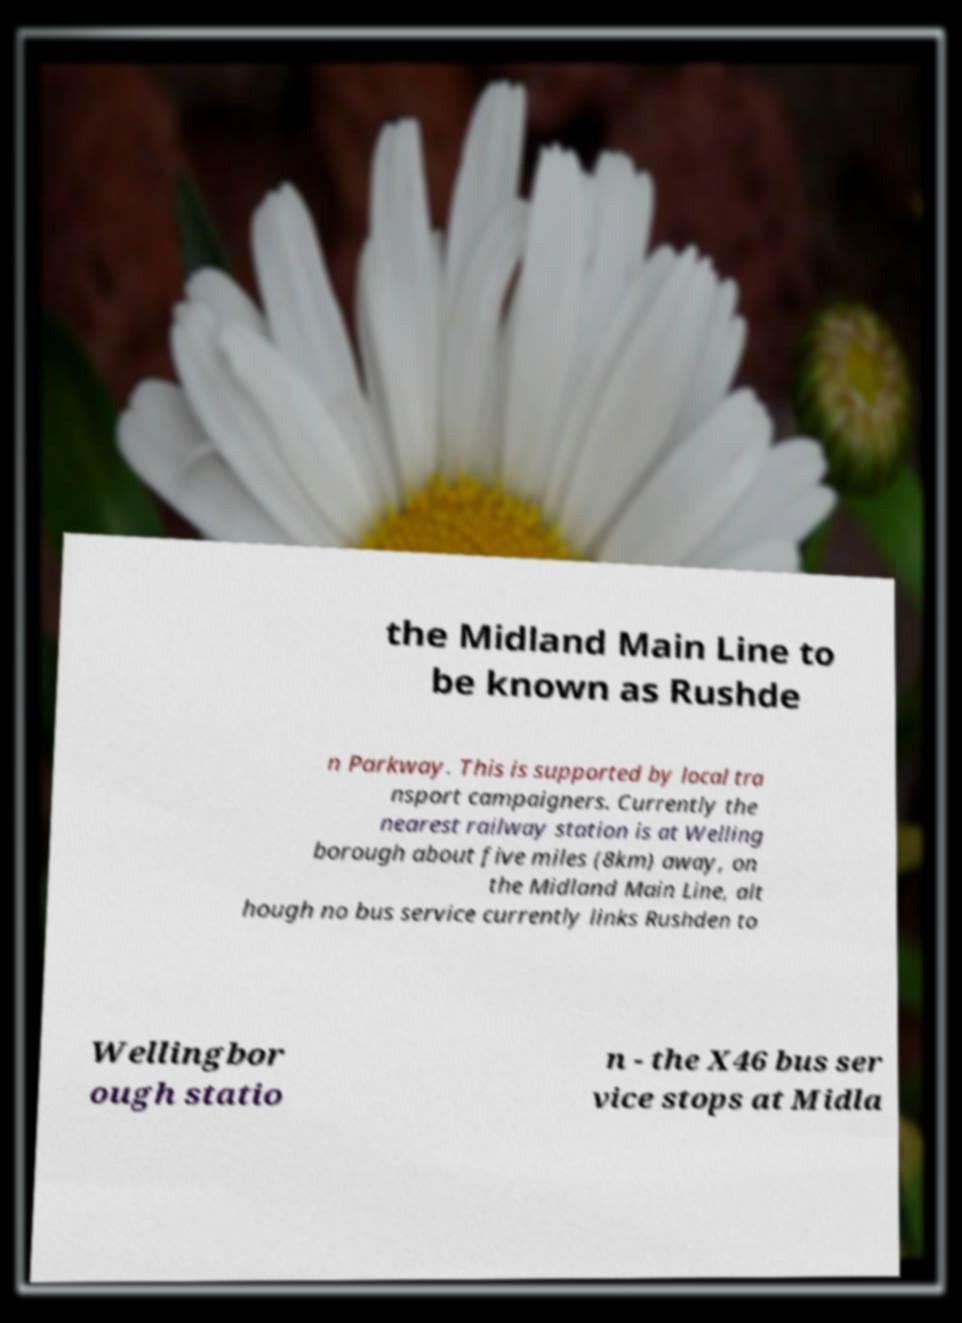Please read and relay the text visible in this image. What does it say? the Midland Main Line to be known as Rushde n Parkway. This is supported by local tra nsport campaigners. Currently the nearest railway station is at Welling borough about five miles (8km) away, on the Midland Main Line, alt hough no bus service currently links Rushden to Wellingbor ough statio n - the X46 bus ser vice stops at Midla 